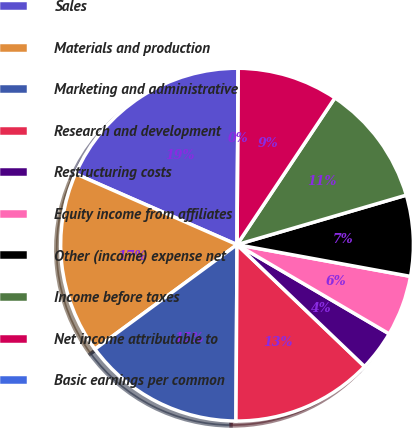Convert chart. <chart><loc_0><loc_0><loc_500><loc_500><pie_chart><fcel>Sales<fcel>Materials and production<fcel>Marketing and administrative<fcel>Research and development<fcel>Restructuring costs<fcel>Equity income from affiliates<fcel>Other (income) expense net<fcel>Income before taxes<fcel>Net income attributable to<fcel>Basic earnings per common<nl><fcel>18.52%<fcel>16.67%<fcel>14.81%<fcel>12.96%<fcel>3.7%<fcel>5.56%<fcel>7.41%<fcel>11.11%<fcel>9.26%<fcel>0.0%<nl></chart> 